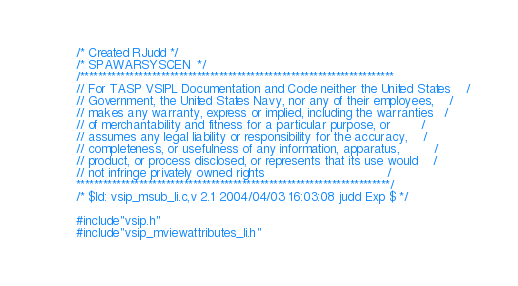Convert code to text. <code><loc_0><loc_0><loc_500><loc_500><_C_>/* Created RJudd */
/* SPAWARSYSCEN  */
/**********************************************************************
// For TASP VSIPL Documentation and Code neither the United States    /
// Government, the United States Navy, nor any of their employees,    /
// makes any warranty, express or implied, including the warranties   /
// of merchantability and fitness for a particular purpose, or        /
// assumes any legal liability or responsibility for the accuracy,    /
// completeness, or usefulness of any information, apparatus,         /
// product, or process disclosed, or represents that its use would    /
// not infringe privately owned rights                                /
**********************************************************************/
/* $Id: vsip_msub_li.c,v 2.1 2004/04/03 16:03:08 judd Exp $ */

#include"vsip.h"
#include"vsip_mviewattributes_li.h"
</code> 